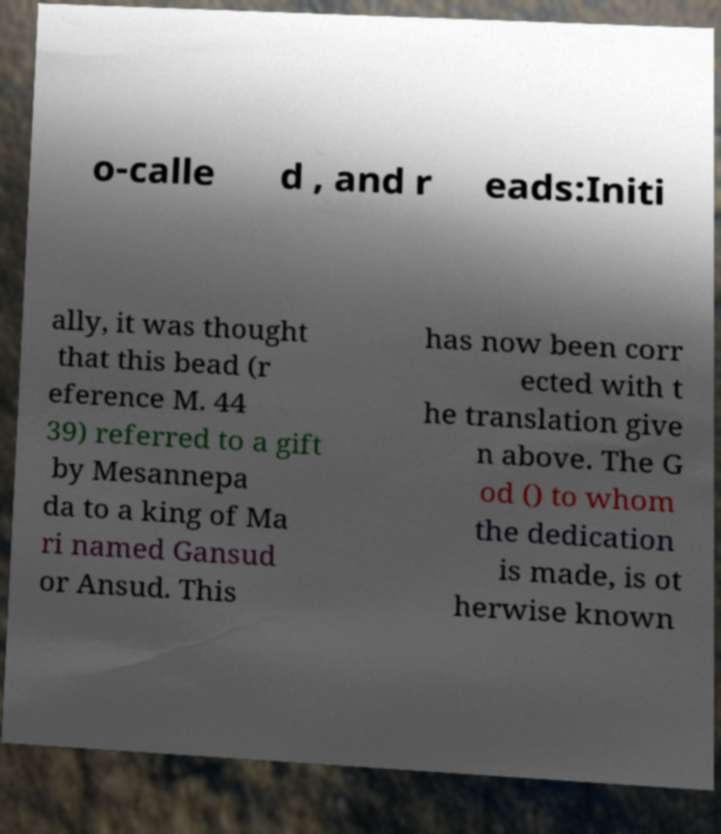Please read and relay the text visible in this image. What does it say? o-calle d , and r eads:Initi ally, it was thought that this bead (r eference M. 44 39) referred to a gift by Mesannepa da to a king of Ma ri named Gansud or Ansud. This has now been corr ected with t he translation give n above. The G od () to whom the dedication is made, is ot herwise known 